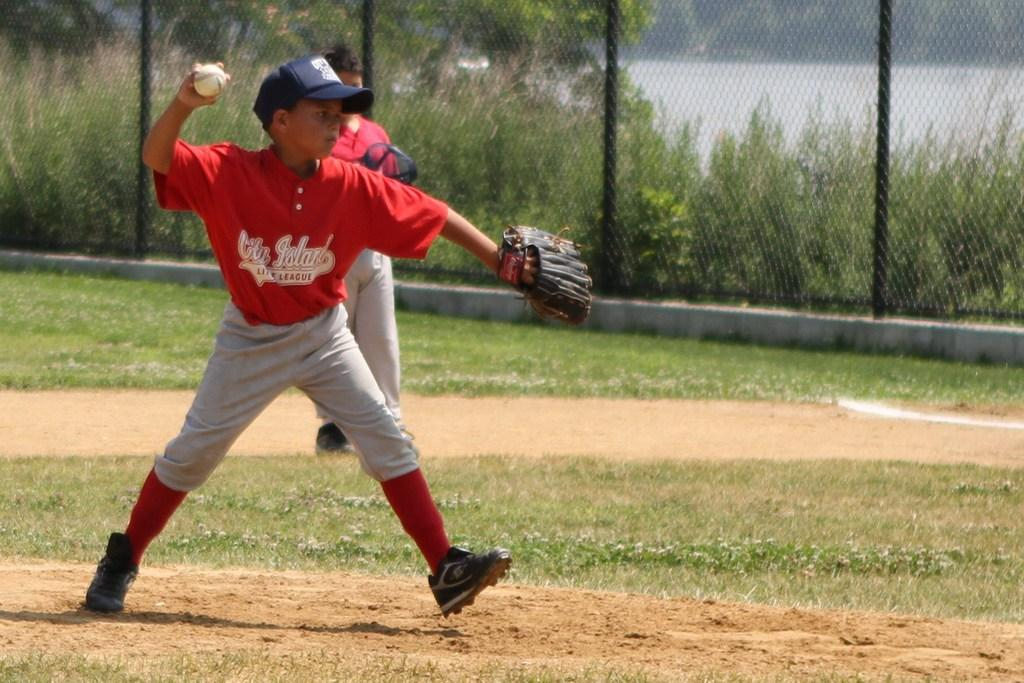<image>
Relay a brief, clear account of the picture shown. A young boy in a red and grey strip who plays for City Island Little League throws the baseball. 